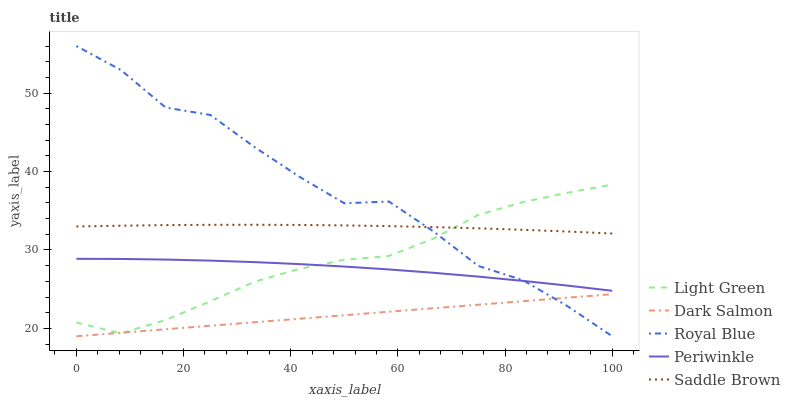Does Dark Salmon have the minimum area under the curve?
Answer yes or no. Yes. Does Royal Blue have the maximum area under the curve?
Answer yes or no. Yes. Does Periwinkle have the minimum area under the curve?
Answer yes or no. No. Does Periwinkle have the maximum area under the curve?
Answer yes or no. No. Is Dark Salmon the smoothest?
Answer yes or no. Yes. Is Royal Blue the roughest?
Answer yes or no. Yes. Is Periwinkle the smoothest?
Answer yes or no. No. Is Periwinkle the roughest?
Answer yes or no. No. Does Royal Blue have the lowest value?
Answer yes or no. Yes. Does Periwinkle have the lowest value?
Answer yes or no. No. Does Royal Blue have the highest value?
Answer yes or no. Yes. Does Periwinkle have the highest value?
Answer yes or no. No. Is Dark Salmon less than Saddle Brown?
Answer yes or no. Yes. Is Saddle Brown greater than Periwinkle?
Answer yes or no. Yes. Does Periwinkle intersect Royal Blue?
Answer yes or no. Yes. Is Periwinkle less than Royal Blue?
Answer yes or no. No. Is Periwinkle greater than Royal Blue?
Answer yes or no. No. Does Dark Salmon intersect Saddle Brown?
Answer yes or no. No. 